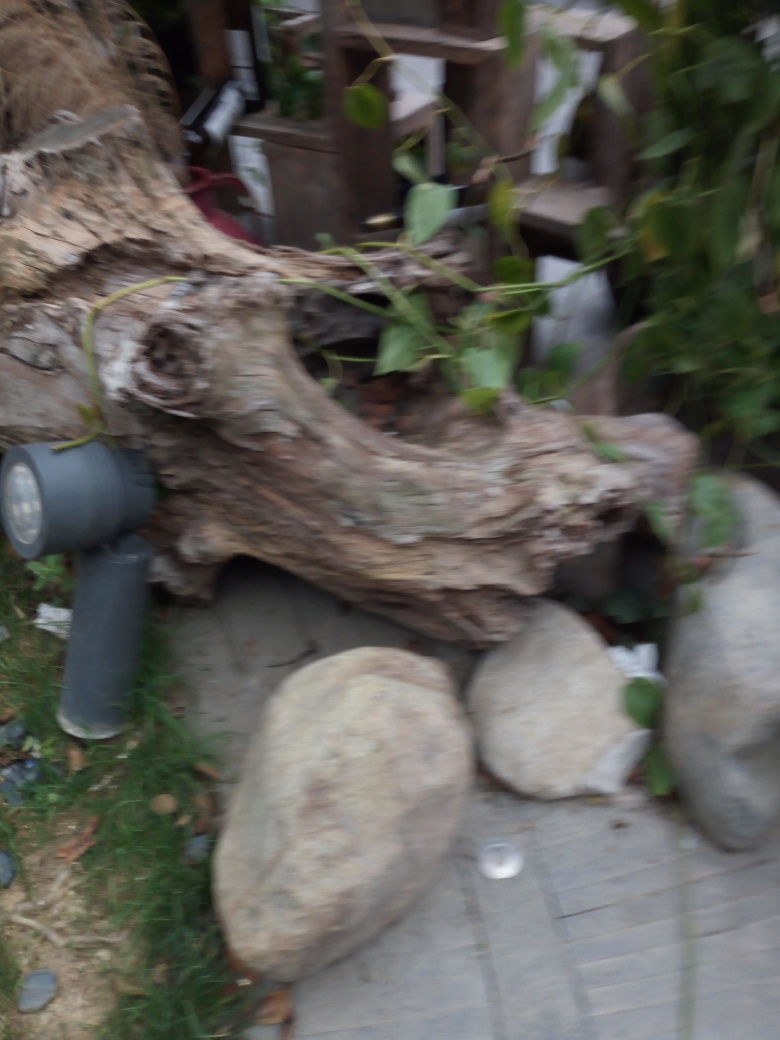Can you describe the setting or environment that's visible in this image? Even though the image is blurry, we can observe a natural setting with what appears to be an uprooted tree stump, stones, and some green foliage. The surrounding elements suggest an outdoor area, possibly a garden or park space, that has a rustic and slightly untamed character. 